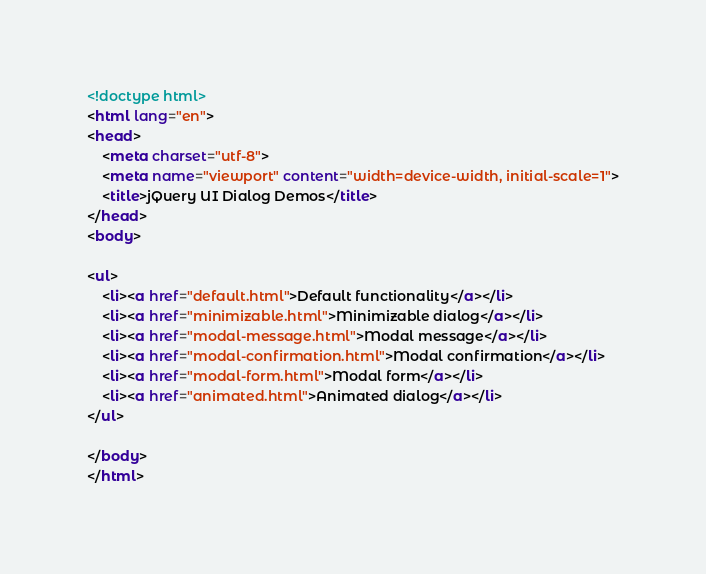<code> <loc_0><loc_0><loc_500><loc_500><_HTML_><!doctype html>
<html lang="en">
<head>
	<meta charset="utf-8">
	<meta name="viewport" content="width=device-width, initial-scale=1">
	<title>jQuery UI Dialog Demos</title>
</head>
<body>

<ul>
	<li><a href="default.html">Default functionality</a></li>
	<li><a href="minimizable.html">Minimizable dialog</a></li>
	<li><a href="modal-message.html">Modal message</a></li>
	<li><a href="modal-confirmation.html">Modal confirmation</a></li>
	<li><a href="modal-form.html">Modal form</a></li>
	<li><a href="animated.html">Animated dialog</a></li>
</ul>

</body>
</html>
</code> 